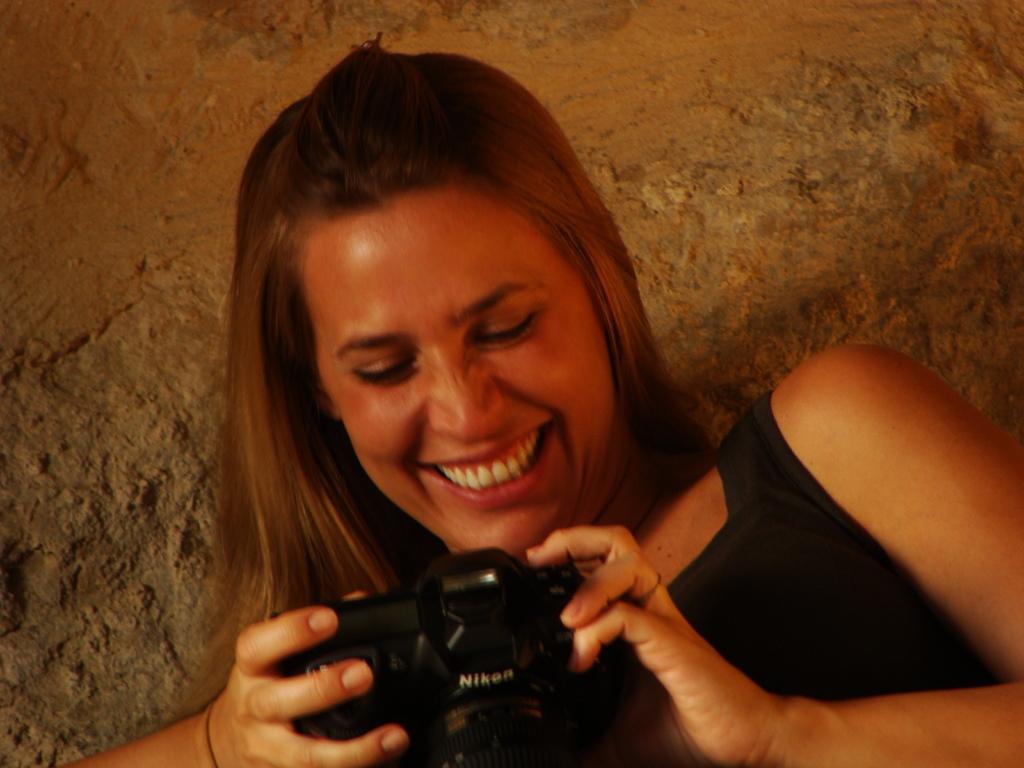Please provide a concise description of this image. In this image there is a woman wearing a black dress and holding a camera. In the background there is a rock. 